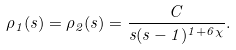Convert formula to latex. <formula><loc_0><loc_0><loc_500><loc_500>\rho _ { 1 } ( s ) = \rho _ { 2 } ( s ) = \frac { C } { s ( s - 1 ) ^ { 1 + 6 \chi } } .</formula> 